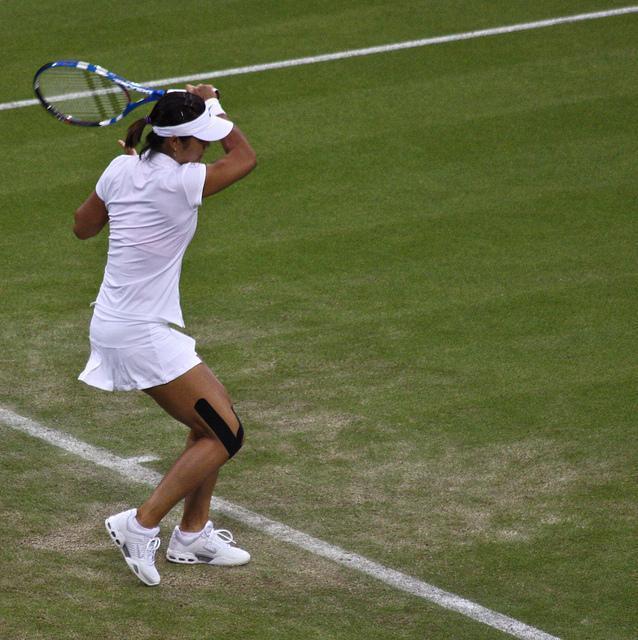How many cats are sleeping in the picture?
Give a very brief answer. 0. 